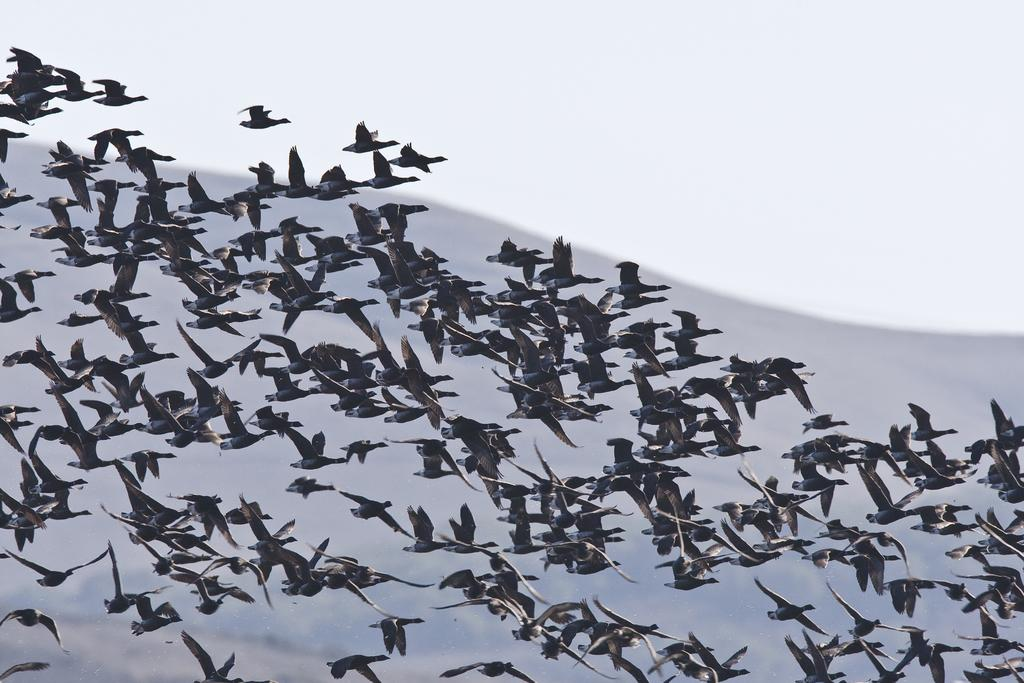What is the main subject of the image? The main subject of the image is many birds. What are the birds doing in the image? The birds are flying in the air. What can be seen in the background of the image? The sky is visible in the background of the image. Can you see any memories in the image? Memories are not visible in the image; it features birds flying in the sky. What type of twig is being used by the birds to fly in the image? There is no twig present in the image; the birds are flying using their wings. 